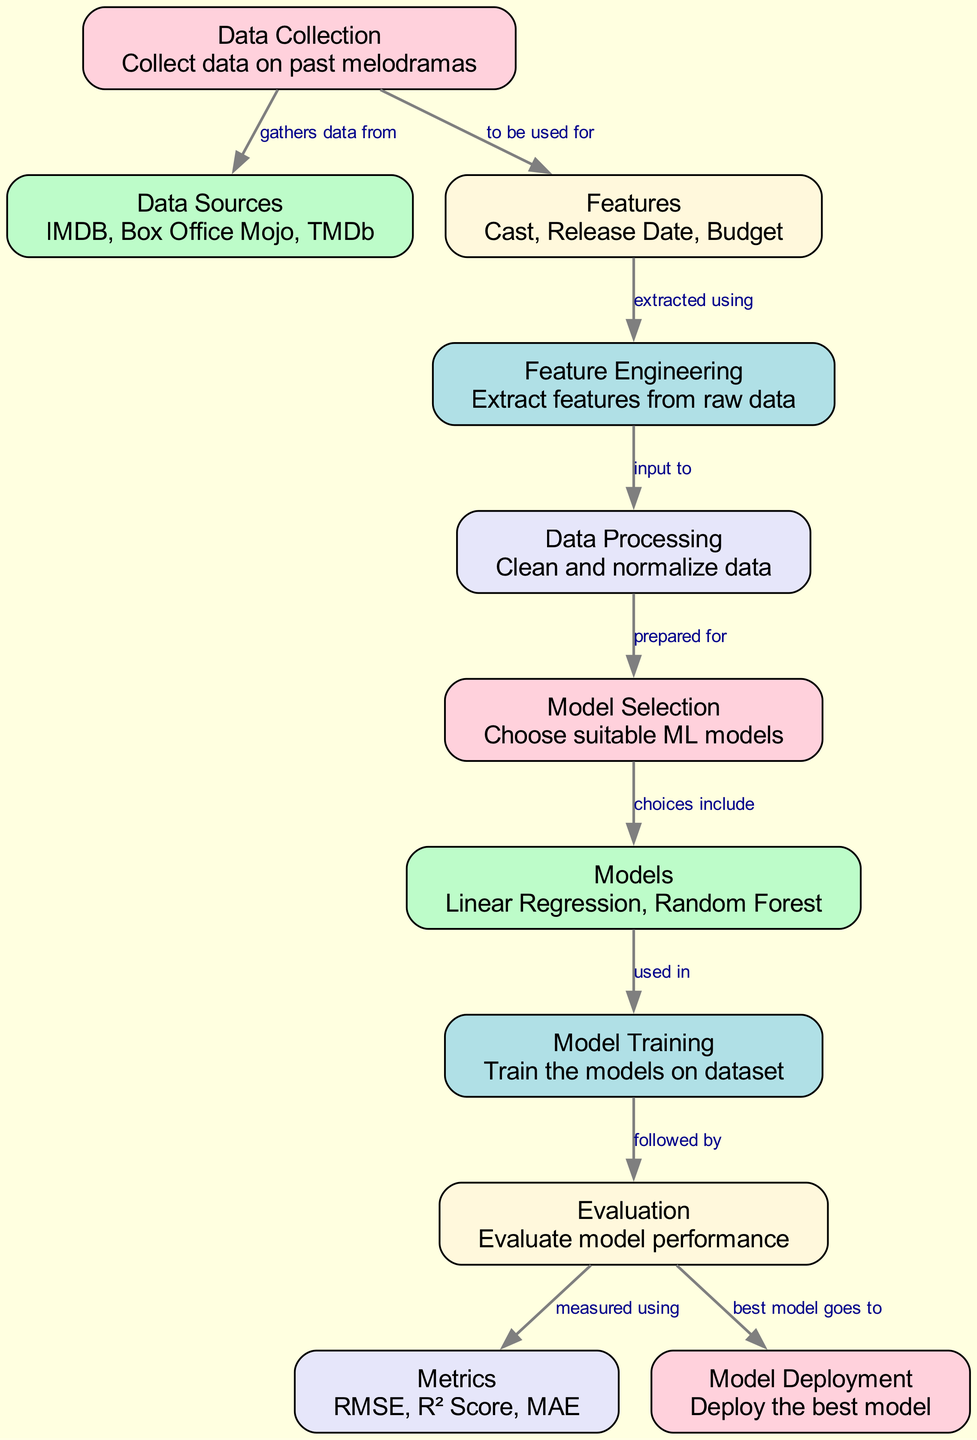What are the data sources used in the diagram? The data sources listed in the diagram are IMDB, Box Office Mojo, and TMDb. This information can be found directly labeled under the "Data Sources" node.
Answer: IMDB, Box Office Mojo, TMDb How many nodes are present in the diagram? The total number of nodes in the diagram is eleven. By counting each individually labeled node shown in the diagram, we can confirm this total.
Answer: eleven What follows after "Feature Engineering"? After "Feature Engineering," the next step in the diagram is "Data Processing". This connection is indicated by the arrow (edge) showing the relationship in the flow.
Answer: Data Processing Which models are selected for use in model training? The selected models are Linear Regression and Random Forest, as stated in the "Models" node. This node indicates the choices available for the model training process.
Answer: Linear Regression, Random Forest What metrics are used to evaluate the model performance? The evaluation metrics mentioned in the diagram include RMSE, R² Score, and MAE. This information is detailed under the "Metrics" node.
Answer: RMSE, R² Score, MAE What is the first step in predicting box office success? The first step in the diagram is "Data Collection," which is the starting point for gathering necessary data. It is the first node shown in the diagram.
Answer: Data Collection How is "Features" related to "Feature Engineering"? "Features" is extracted using "Feature Engineering," as clarifying the relationship between these two nodes, indicated by the edge that connects them with a labeled arrow.
Answer: extracted using What is the output of the "Evaluation"? The output of the "Evaluation" is the "Metrics," which reflect how the model performance is assessed. This relationship is shown by the directed edge leading from "Evaluation" to "Metrics."
Answer: Metrics In which step is the best model deployed? The best model is deployed in the "Model Deployment" step, which follows the "Evaluation" step. This is explicitly shown by the directed edge leading to the "Deployment" node.
Answer: Model Deployment 